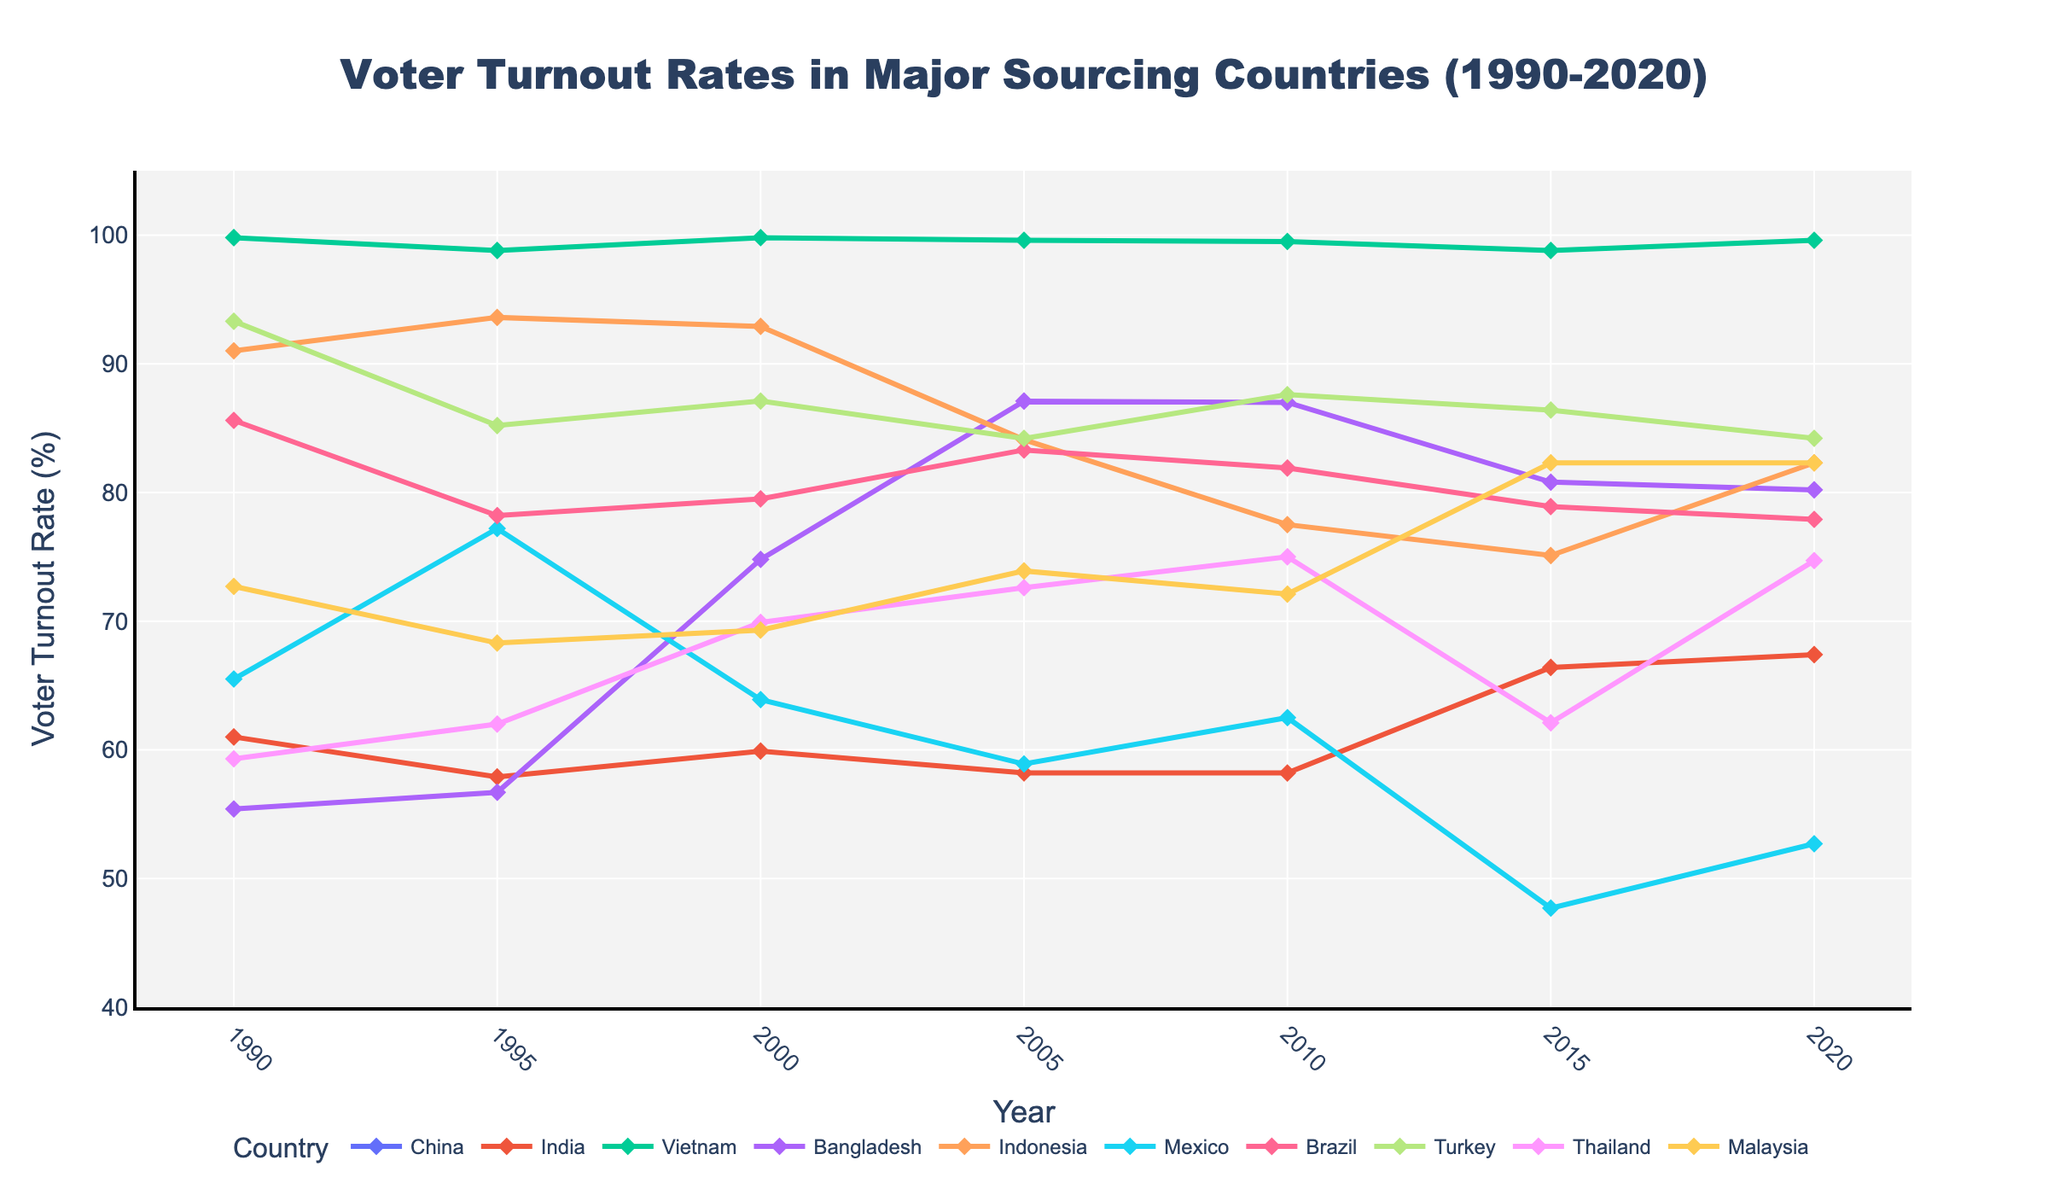What was the voter turnout rate in India in 2020? Looking at the line plot for India, the voter turnout rate in 2020 is indicated near the top of the line.
Answer: 67.4% Which country had the highest voter turnout rate in 1990? Examining the line plots for all countries, Vietnam’s plot starts at the highest point in 1990, indicating the highest voter turnout rate.
Answer: Vietnam What is the difference in voter turnout rate between Brazil and Turkey in 2015? From the line plots for Brazil and Turkey at the year 2015, subtract Brazil's rate (78.9%) from Turkey's rate (86.4%). 86.4% - 78.9% = 7.5%
Answer: 7.5% Which country has shown the most decline in voter turnout rate from 1995 to 2015? By measuring the slopes of the lines for each country between 1995 and 2015, Mexico has a significant downward slope indicating the largest decline.
Answer: Mexico What is the average voter turnout rate in Bangladesh over the years provided? To find the average, sum the voter turnout rates for Bangladesh across all the available years and divide by the number of years: (55.4 + 56.7 + 74.8 + 87.1 + 87.0 + 80.8 + 80.2)/7 = 74.29
Answer: 74.3 In which year did Indonesia experience its lowest voter turnout rate? By tracing the line plot for Indonesia across all years, the lowest point on the line occurs in 2015.
Answer: 2015 Compare the voter turnout rates between Malaysia and Thailand in 2020. Which country had a higher turnout rate? Examine the line plots for both Malaysia and Thailand in the year 2020. Malaysia’s plot is slightly higher than Thailand’s.
Answer: Malaysia Which country maintained a relatively high and stable voter turnout rate throughout the years? Vietnam's line plot stays consistently near the top and shows minimal variation, indicating a high and stable voter turnout rate.
Answer: Vietnam By how much did the voter turnout rate in India change between 2000 and 2015? Identify the voter turnout rates for India in 2000 and 2015, and calculate the change: 66.4% (2015) - 59.9% (2000) = 6.5%
Answer: 6.5% What is the range of voter turnout rates in Mexico across the years provided? Find the highest and lowest voter turnout rates for Mexico: Highest is 77.2% (1995) and lowest is 47.7% (2015). The range is 77.2% - 47.7% = 29.5%
Answer: 29.5% Which countries have voter turnout rates that never fell below 70%? By examining the line plots of each country, Malaysia and Vietnam never fall below the 70% mark over the given years.
Answer: Malaysia, Vietnam 